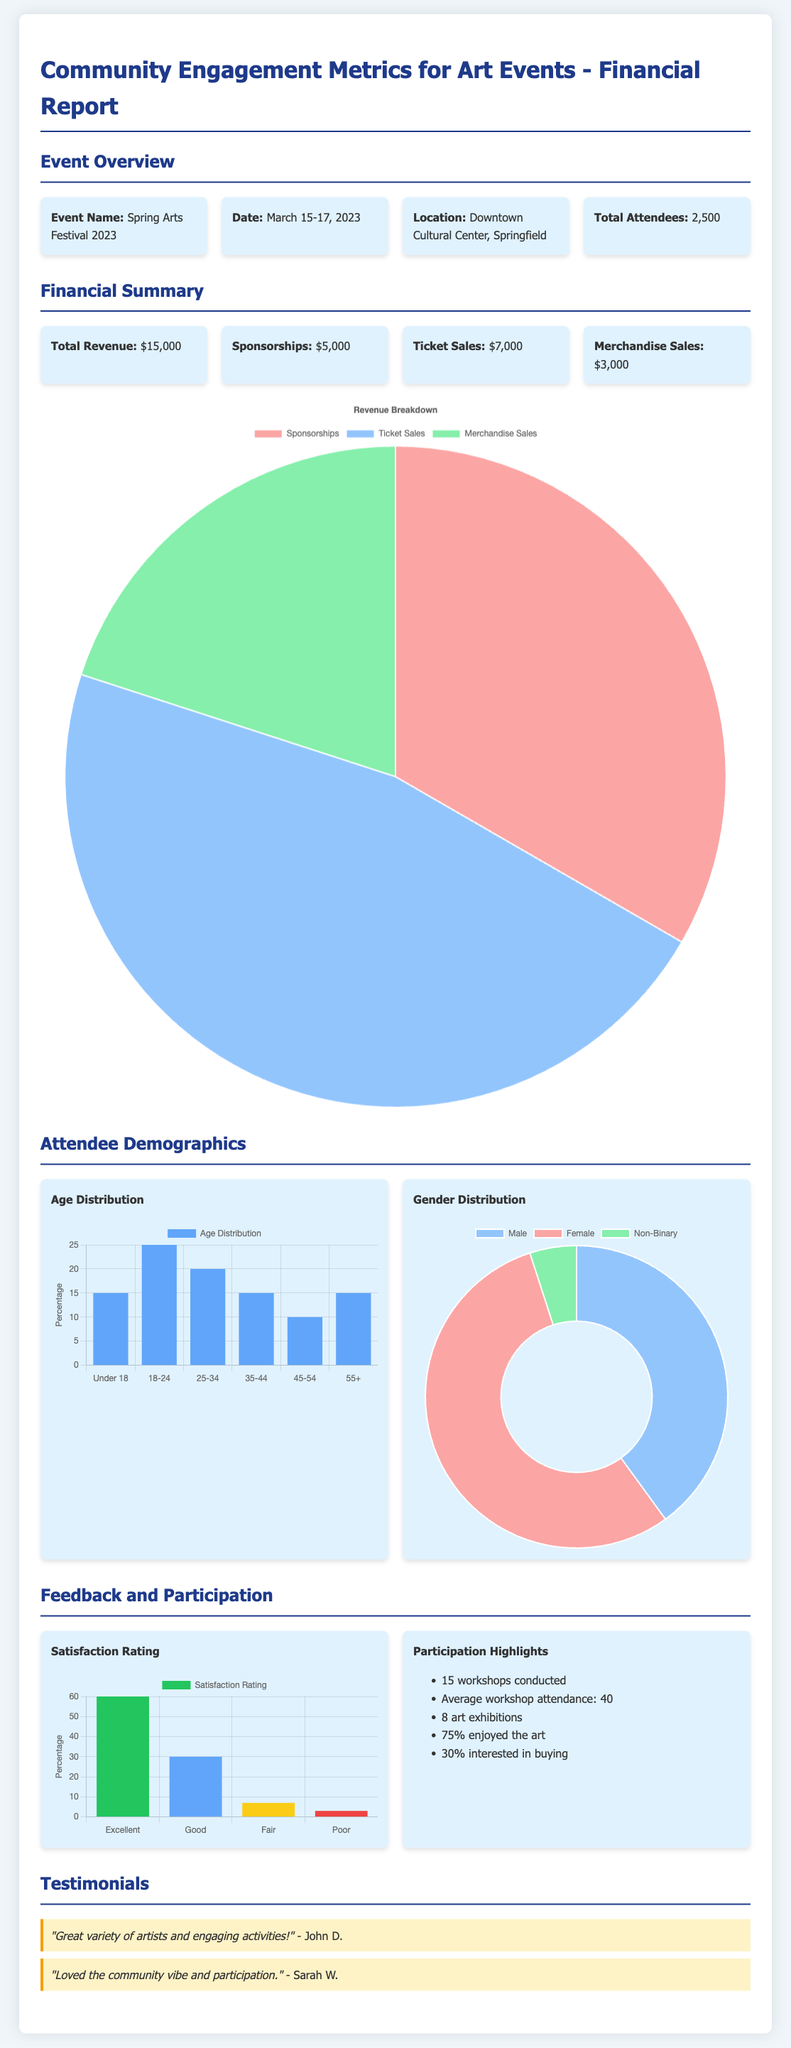What is the event name? The event name is explicitly mentioned in the document.
Answer: Spring Arts Festival 2023 What was the date of the event? The document clearly states the date of the event.
Answer: March 15-17, 2023 What was the total number of attendees? The total number of attendees is provided in the event overview section.
Answer: 2,500 What is the total revenue generated? The total revenue can be found under the financial summary section.
Answer: $15,000 What percentage of attendees rated their satisfaction as Excellent? The satisfaction ratings are represented in a bar chart, which shows the percentage of respondents.
Answer: 60% Which age group had the highest representation at the event? The age distribution chart indicates the percentage distribution across different age groups.
Answer: 18-24 What is the percentage of female attendees? The gender distribution chart provides the percentage of female attendees.
Answer: 55% How many workshops were conducted during the event? The number of workshops is mentioned under the participation highlights section.
Answer: 15 What feedback did John D. provide? A testimonial section summarizes attendee feedback, including John D.'s comment.
Answer: "Great variety of artists and engaging activities!" 